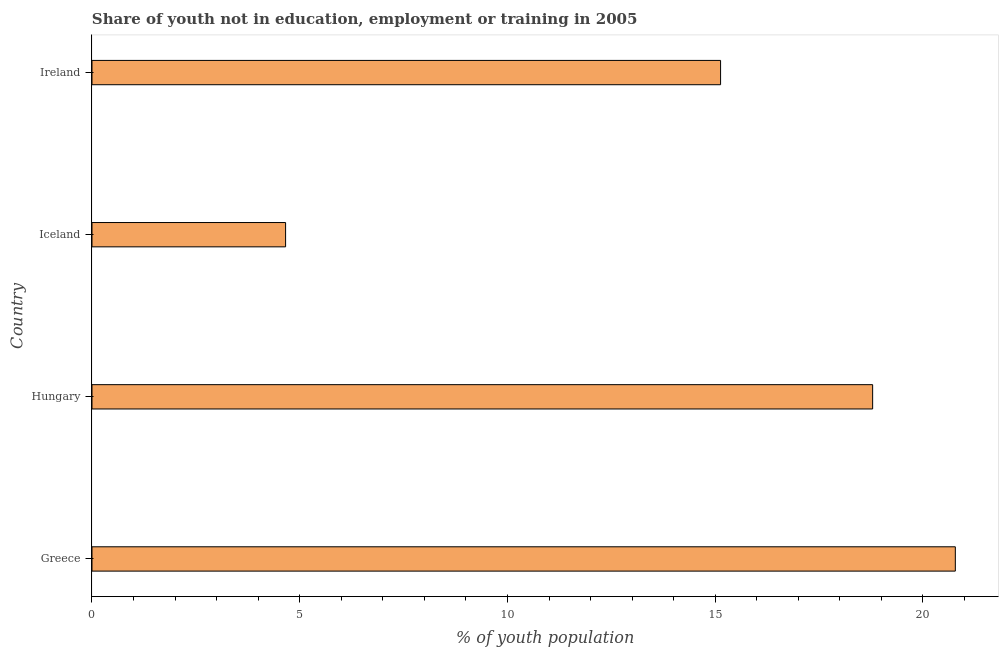Does the graph contain any zero values?
Offer a terse response. No. Does the graph contain grids?
Provide a short and direct response. No. What is the title of the graph?
Make the answer very short. Share of youth not in education, employment or training in 2005. What is the label or title of the X-axis?
Your response must be concise. % of youth population. What is the unemployed youth population in Greece?
Offer a terse response. 20.78. Across all countries, what is the maximum unemployed youth population?
Your answer should be compact. 20.78. Across all countries, what is the minimum unemployed youth population?
Give a very brief answer. 4.66. What is the sum of the unemployed youth population?
Give a very brief answer. 59.36. What is the difference between the unemployed youth population in Greece and Ireland?
Your answer should be very brief. 5.65. What is the average unemployed youth population per country?
Provide a short and direct response. 14.84. What is the median unemployed youth population?
Give a very brief answer. 16.96. In how many countries, is the unemployed youth population greater than 19 %?
Keep it short and to the point. 1. What is the ratio of the unemployed youth population in Greece to that in Ireland?
Provide a succinct answer. 1.37. Is the unemployed youth population in Greece less than that in Hungary?
Give a very brief answer. No. Is the difference between the unemployed youth population in Greece and Ireland greater than the difference between any two countries?
Provide a succinct answer. No. What is the difference between the highest and the second highest unemployed youth population?
Your answer should be very brief. 1.99. What is the difference between the highest and the lowest unemployed youth population?
Provide a short and direct response. 16.12. In how many countries, is the unemployed youth population greater than the average unemployed youth population taken over all countries?
Give a very brief answer. 3. How many bars are there?
Give a very brief answer. 4. What is the % of youth population of Greece?
Your answer should be very brief. 20.78. What is the % of youth population of Hungary?
Provide a short and direct response. 18.79. What is the % of youth population of Iceland?
Offer a very short reply. 4.66. What is the % of youth population in Ireland?
Provide a succinct answer. 15.13. What is the difference between the % of youth population in Greece and Hungary?
Provide a short and direct response. 1.99. What is the difference between the % of youth population in Greece and Iceland?
Your response must be concise. 16.12. What is the difference between the % of youth population in Greece and Ireland?
Offer a terse response. 5.65. What is the difference between the % of youth population in Hungary and Iceland?
Give a very brief answer. 14.13. What is the difference between the % of youth population in Hungary and Ireland?
Make the answer very short. 3.66. What is the difference between the % of youth population in Iceland and Ireland?
Offer a very short reply. -10.47. What is the ratio of the % of youth population in Greece to that in Hungary?
Provide a short and direct response. 1.11. What is the ratio of the % of youth population in Greece to that in Iceland?
Your response must be concise. 4.46. What is the ratio of the % of youth population in Greece to that in Ireland?
Give a very brief answer. 1.37. What is the ratio of the % of youth population in Hungary to that in Iceland?
Your response must be concise. 4.03. What is the ratio of the % of youth population in Hungary to that in Ireland?
Provide a short and direct response. 1.24. What is the ratio of the % of youth population in Iceland to that in Ireland?
Offer a very short reply. 0.31. 